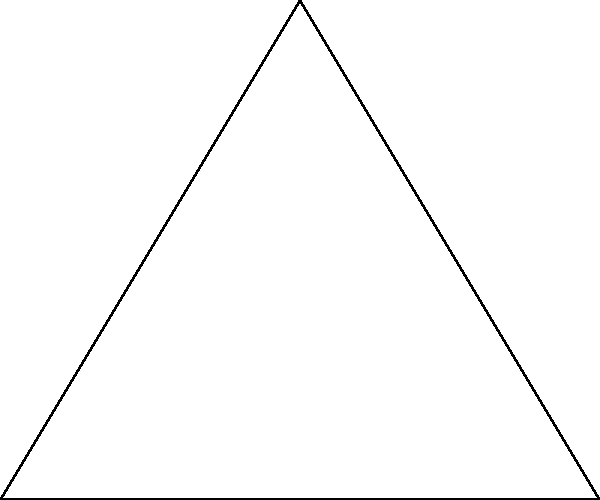As a city planner, you're tasked with optimizing the placement of three circular water towers to maximize coverage area in a triangular region. The region is represented by a triangle with vertices at coordinates A(0,0), B(6,0), and C(3,5). Each water tower has a coverage radius of 2 units. What is the total area of the triangle that remains uncovered by the water towers when they are placed at the vertices of the triangle? To solve this problem, we need to follow these steps:

1) Calculate the area of the triangle:
   Area of triangle = $\frac{1}{2} \times base \times height$
   $= \frac{1}{2} \times 6 \times 5 = 15$ square units

2) Calculate the area of a single circular water tower:
   Area of circle = $\pi r^2 = \pi \times 2^2 = 4\pi$ square units

3) Calculate the area of the circular sectors within the triangle for each tower:
   - For towers at A and B, the sector angle is 60°
   - For the tower at C, the sector angle is 60°
   
   Area of sector = $\frac{\theta}{360°} \times \pi r^2 = \frac{60}{360} \times 4\pi = \frac{2\pi}{3}$ square units

4) Calculate the total covered area:
   Total covered area = $3 \times \frac{2\pi}{3} = 2\pi$ square units

5) Calculate the uncovered area:
   Uncovered area = Total triangle area - Covered area
   $= 15 - 2\pi \approx 8.71$ square units

Therefore, approximately 8.71 square units of the triangle remain uncovered.
Answer: $15 - 2\pi \approx 8.71$ square units 